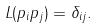<formula> <loc_0><loc_0><loc_500><loc_500>L ( p _ { i } p _ { j } ) = \delta _ { i j } .</formula> 